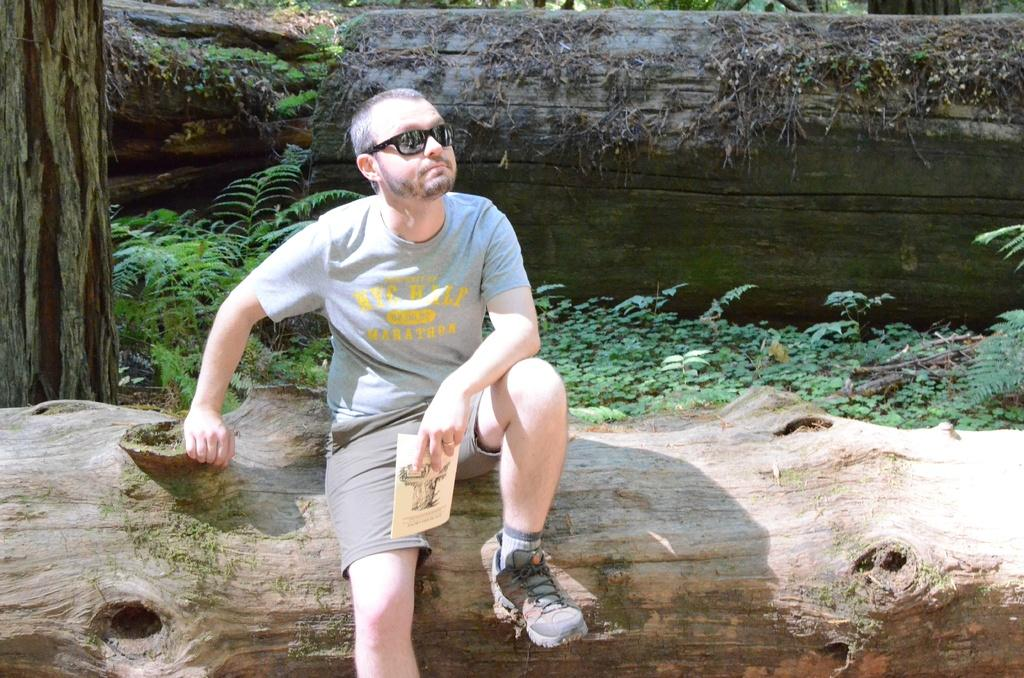What is the person in the image doing? The person is sitting on the trunk of a tree in the image. What else can be seen in the image besides the person? There are plants visible in the image. Can you describe the tree trunk in the background of the image? There is a tree trunk in the background of the image. What is located on the left side of the image? There is a tree on the left side of the image. What type of roll is the person eating while sitting on the tree trunk? There is no roll present in the image; the person is sitting on the trunk of a tree. Can you describe the bear that is climbing the tree on the left side of the image? There is no bear present in the image; only a tree is visible on the left side. 